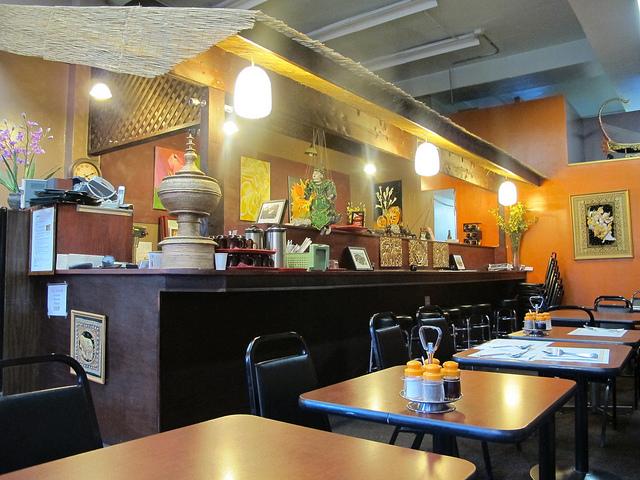Is this a nice restaurant?
Answer briefly. Yes. What is on the dining tables?
Quick response, please. Condiments. Is there anyone in the restaurant?
Write a very short answer. No. 